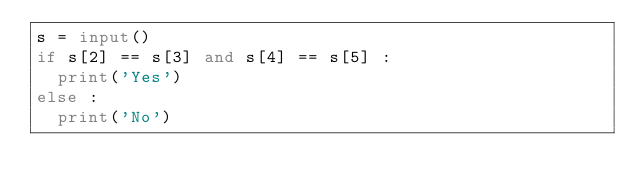Convert code to text. <code><loc_0><loc_0><loc_500><loc_500><_Python_>s = input()
if s[2] == s[3] and s[4] == s[5] :
  print('Yes')
else :
  print('No')</code> 